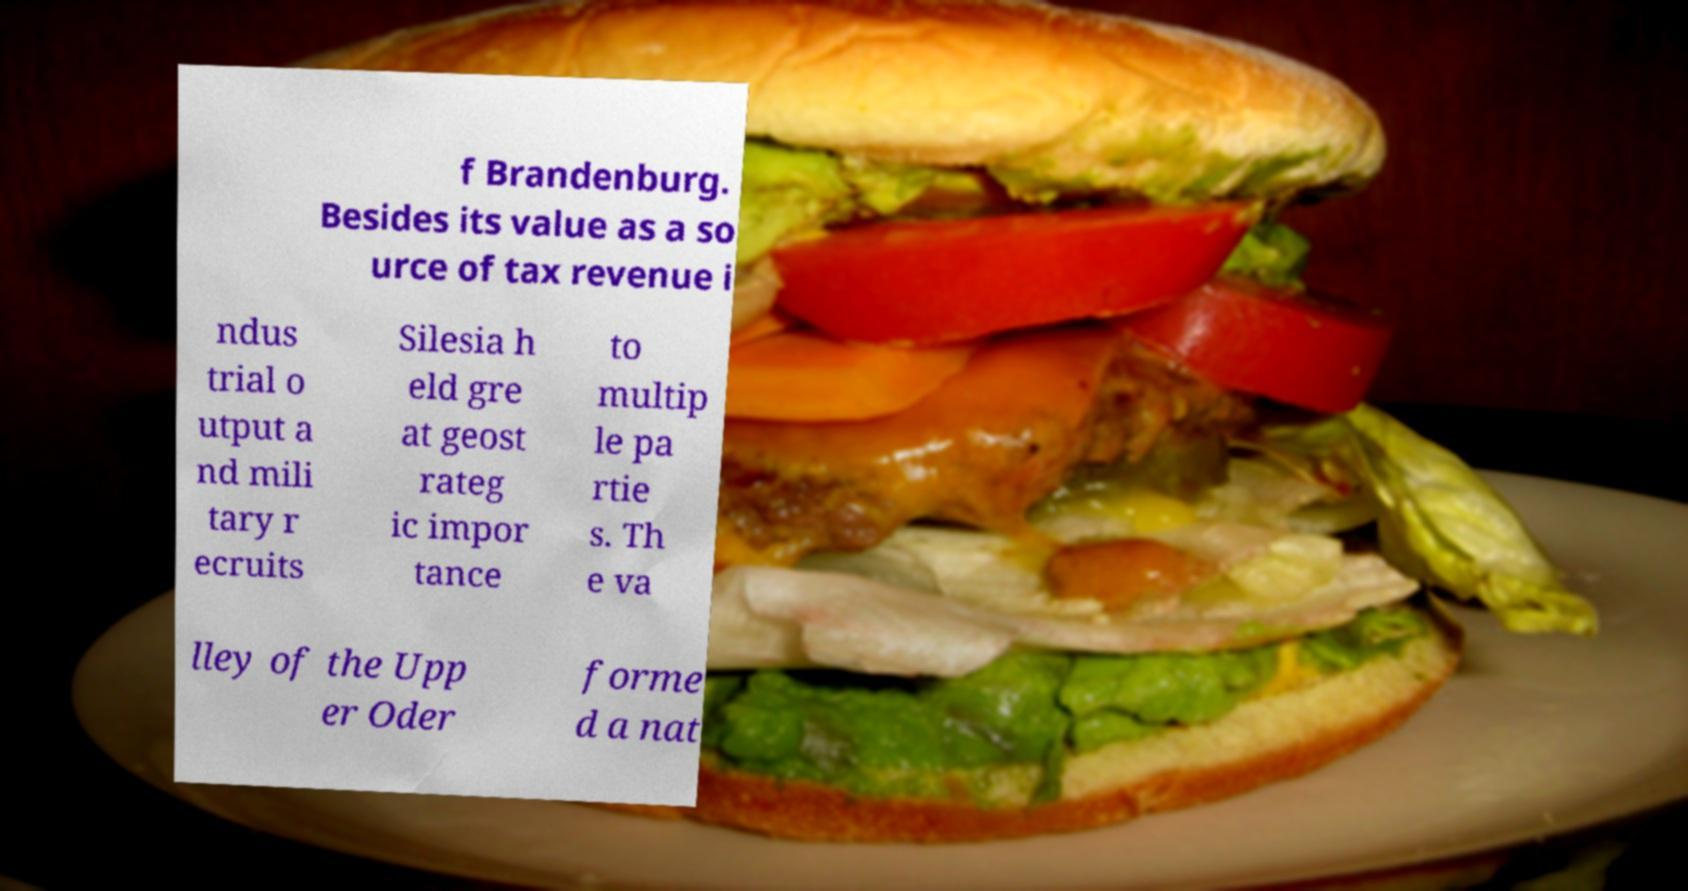For documentation purposes, I need the text within this image transcribed. Could you provide that? f Brandenburg. Besides its value as a so urce of tax revenue i ndus trial o utput a nd mili tary r ecruits Silesia h eld gre at geost rateg ic impor tance to multip le pa rtie s. Th e va lley of the Upp er Oder forme d a nat 